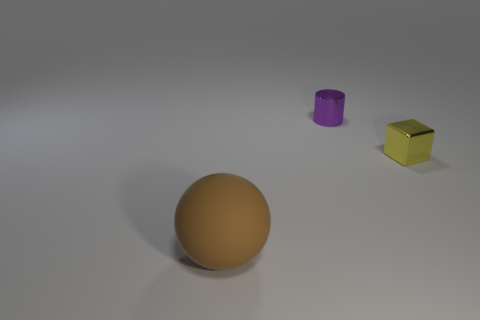There is a thing behind the tiny metallic thing that is on the right side of the tiny purple cylinder; what size is it?
Offer a terse response. Small. What is the material of the object that is in front of the yellow object?
Offer a terse response. Rubber. How many big brown objects have the same shape as the purple metallic object?
Provide a short and direct response. 0. Is the shape of the yellow metal object the same as the thing to the left of the purple shiny object?
Offer a very short reply. No. Are there any tiny yellow cubes made of the same material as the purple cylinder?
Your response must be concise. Yes. Is there anything else that is made of the same material as the large thing?
Your response must be concise. No. The object that is in front of the tiny thing that is right of the purple cylinder is made of what material?
Your answer should be compact. Rubber. There is a thing that is in front of the small object in front of the small object that is behind the tiny block; what size is it?
Offer a very short reply. Large. How many other things are there of the same shape as the small yellow metallic object?
Your answer should be compact. 0. There is another object that is the same size as the yellow thing; what is its color?
Ensure brevity in your answer.  Purple. 